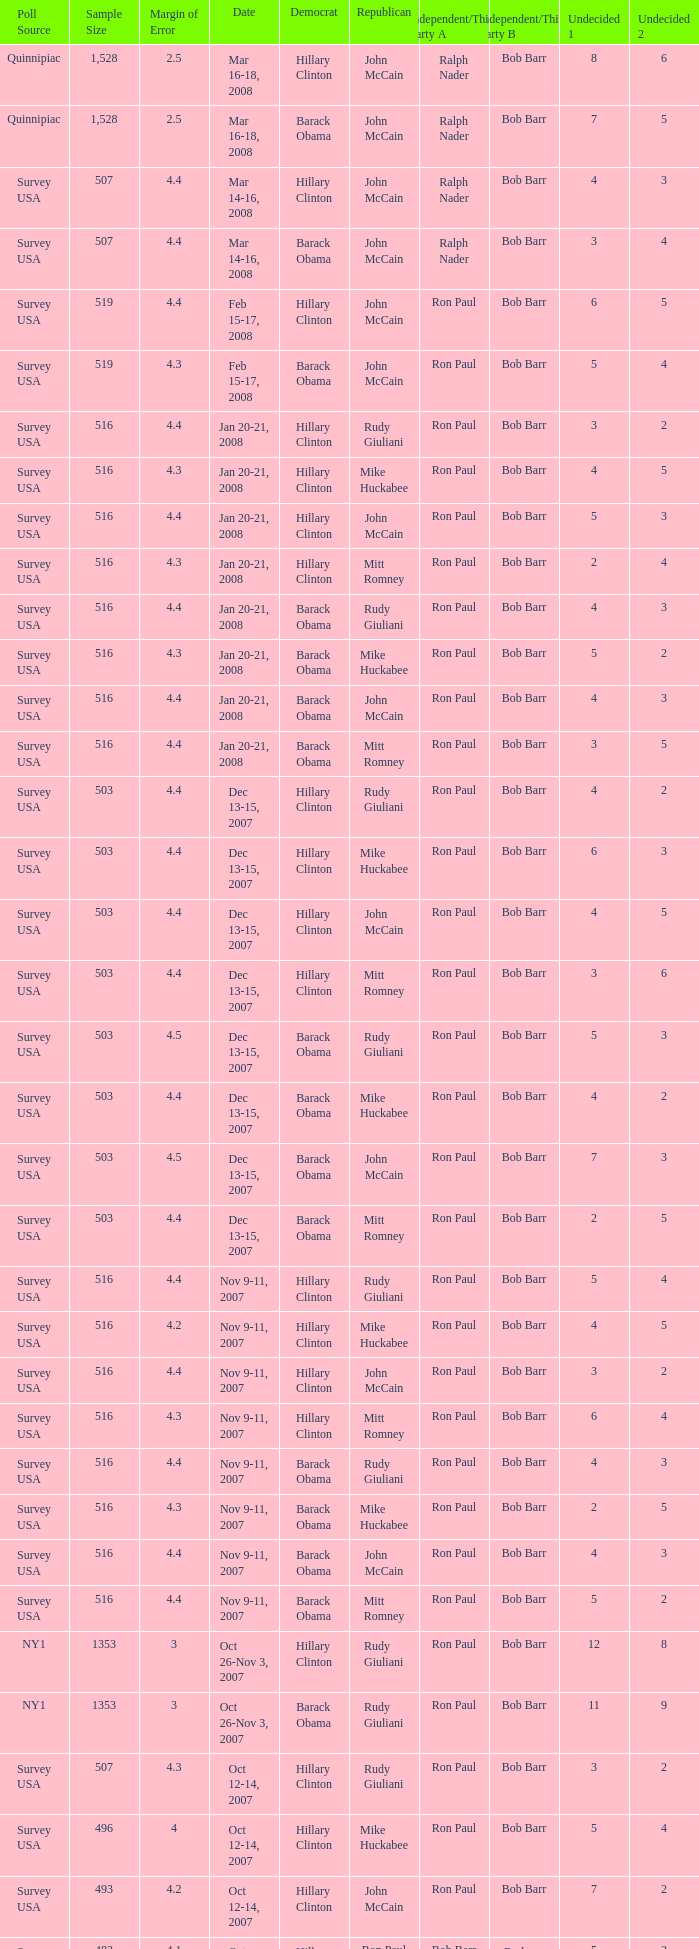Which Democrat was selected in the poll with a sample size smaller than 516 where the Republican chosen was Ron Paul? Hillary Clinton. 